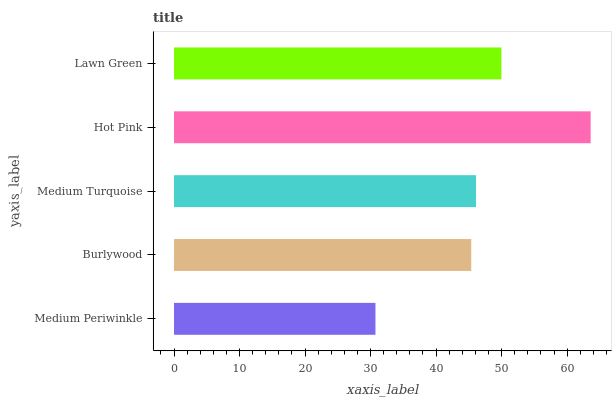Is Medium Periwinkle the minimum?
Answer yes or no. Yes. Is Hot Pink the maximum?
Answer yes or no. Yes. Is Burlywood the minimum?
Answer yes or no. No. Is Burlywood the maximum?
Answer yes or no. No. Is Burlywood greater than Medium Periwinkle?
Answer yes or no. Yes. Is Medium Periwinkle less than Burlywood?
Answer yes or no. Yes. Is Medium Periwinkle greater than Burlywood?
Answer yes or no. No. Is Burlywood less than Medium Periwinkle?
Answer yes or no. No. Is Medium Turquoise the high median?
Answer yes or no. Yes. Is Medium Turquoise the low median?
Answer yes or no. Yes. Is Medium Periwinkle the high median?
Answer yes or no. No. Is Hot Pink the low median?
Answer yes or no. No. 